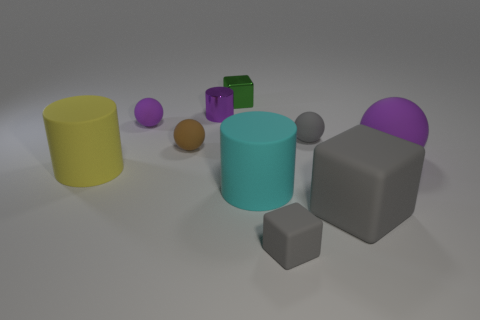There is a purple ball that is behind the purple thing right of the green metallic cube; is there a yellow object behind it?
Give a very brief answer. No. How big is the thing that is in front of the yellow cylinder and behind the large gray object?
Ensure brevity in your answer.  Large. How many brown things are made of the same material as the big sphere?
Offer a terse response. 1. What number of spheres are either cyan metal objects or green objects?
Offer a terse response. 0. Are there the same number of tiny blocks and small brown metallic blocks?
Make the answer very short. No. There is a gray rubber cube to the right of the tiny rubber object that is in front of the matte cylinder that is to the left of the cyan matte cylinder; what is its size?
Provide a short and direct response. Large. There is a matte ball that is on the left side of the big purple sphere and on the right side of the tiny shiny cylinder; what color is it?
Provide a succinct answer. Gray. Do the purple cylinder and the cylinder to the right of the tiny shiny cylinder have the same size?
Give a very brief answer. No. Are there any other things that are the same shape as the green thing?
Your answer should be compact. Yes. What color is the other big object that is the same shape as the yellow rubber object?
Offer a very short reply. Cyan. 